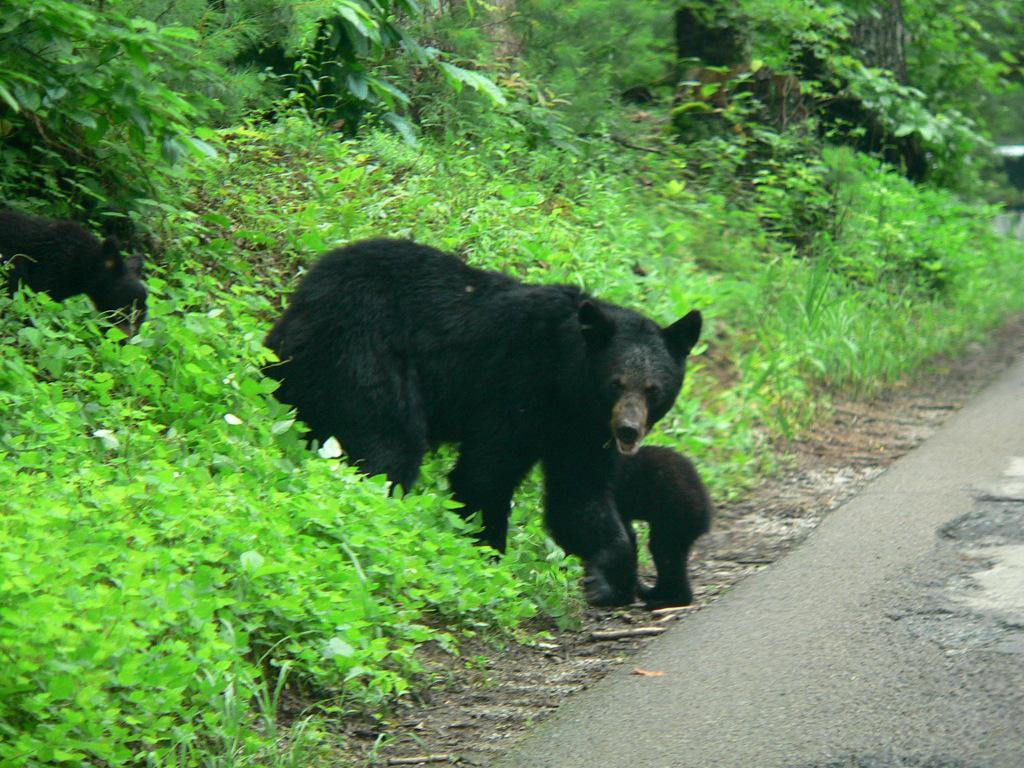What type of living organisms can be seen in the image? There are animals in the image. What is the color of the animals in the image? The animals are black in color. What type of natural environment is visible in the image? There are many trees in the image. What man-made structure can be seen in the image? There is a road visible in the image. How many pots can be seen in the image? There are no pots present in the image. What type of insect is crawling on the animals in the image? There are no insects, including ladybugs, present in the image. 